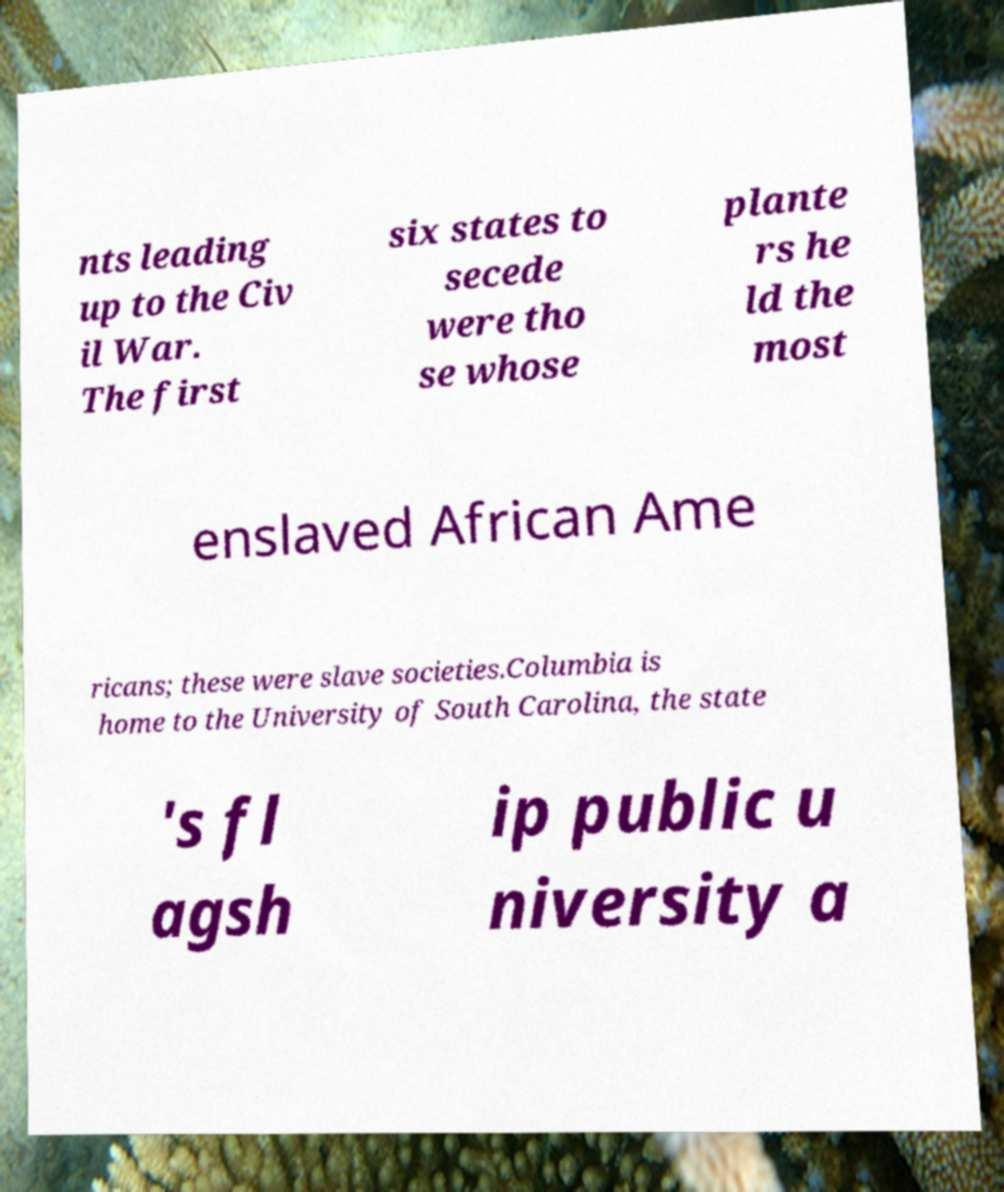I need the written content from this picture converted into text. Can you do that? nts leading up to the Civ il War. The first six states to secede were tho se whose plante rs he ld the most enslaved African Ame ricans; these were slave societies.Columbia is home to the University of South Carolina, the state 's fl agsh ip public u niversity a 